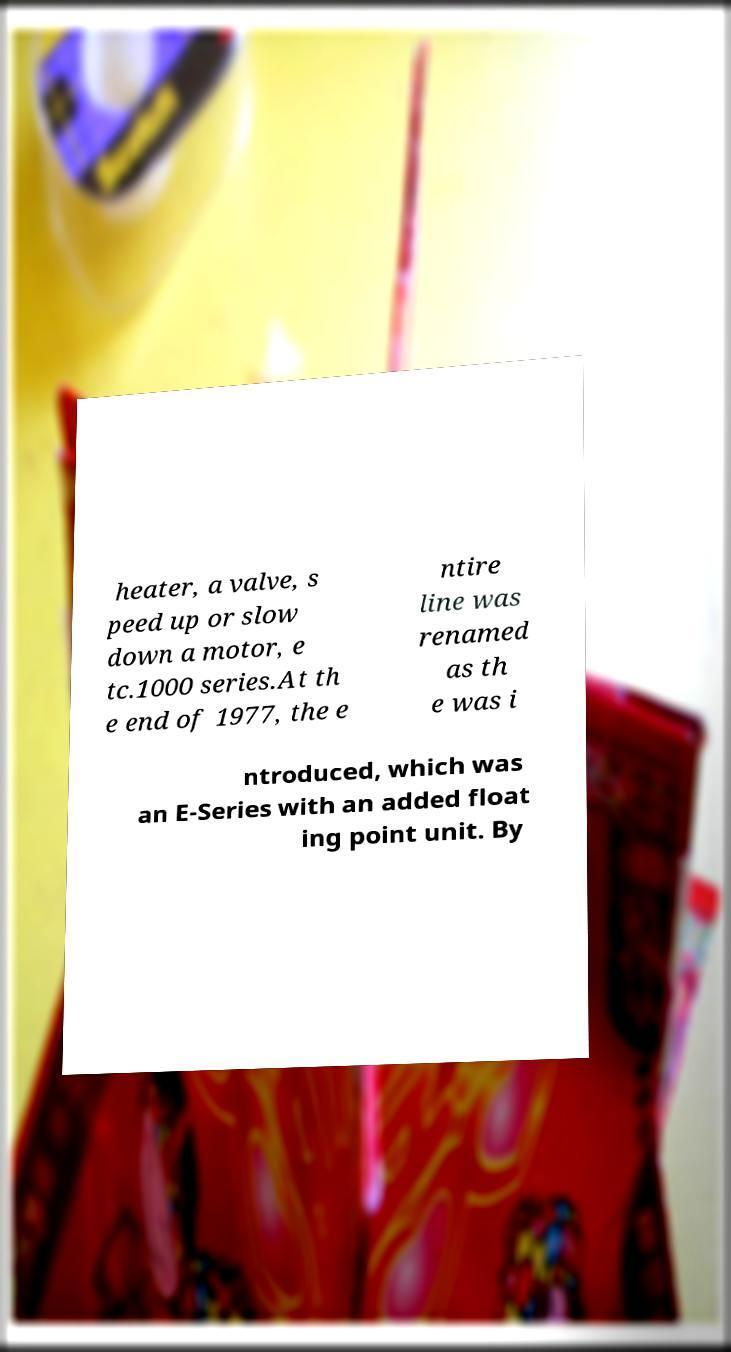Could you extract and type out the text from this image? heater, a valve, s peed up or slow down a motor, e tc.1000 series.At th e end of 1977, the e ntire line was renamed as th e was i ntroduced, which was an E-Series with an added float ing point unit. By 